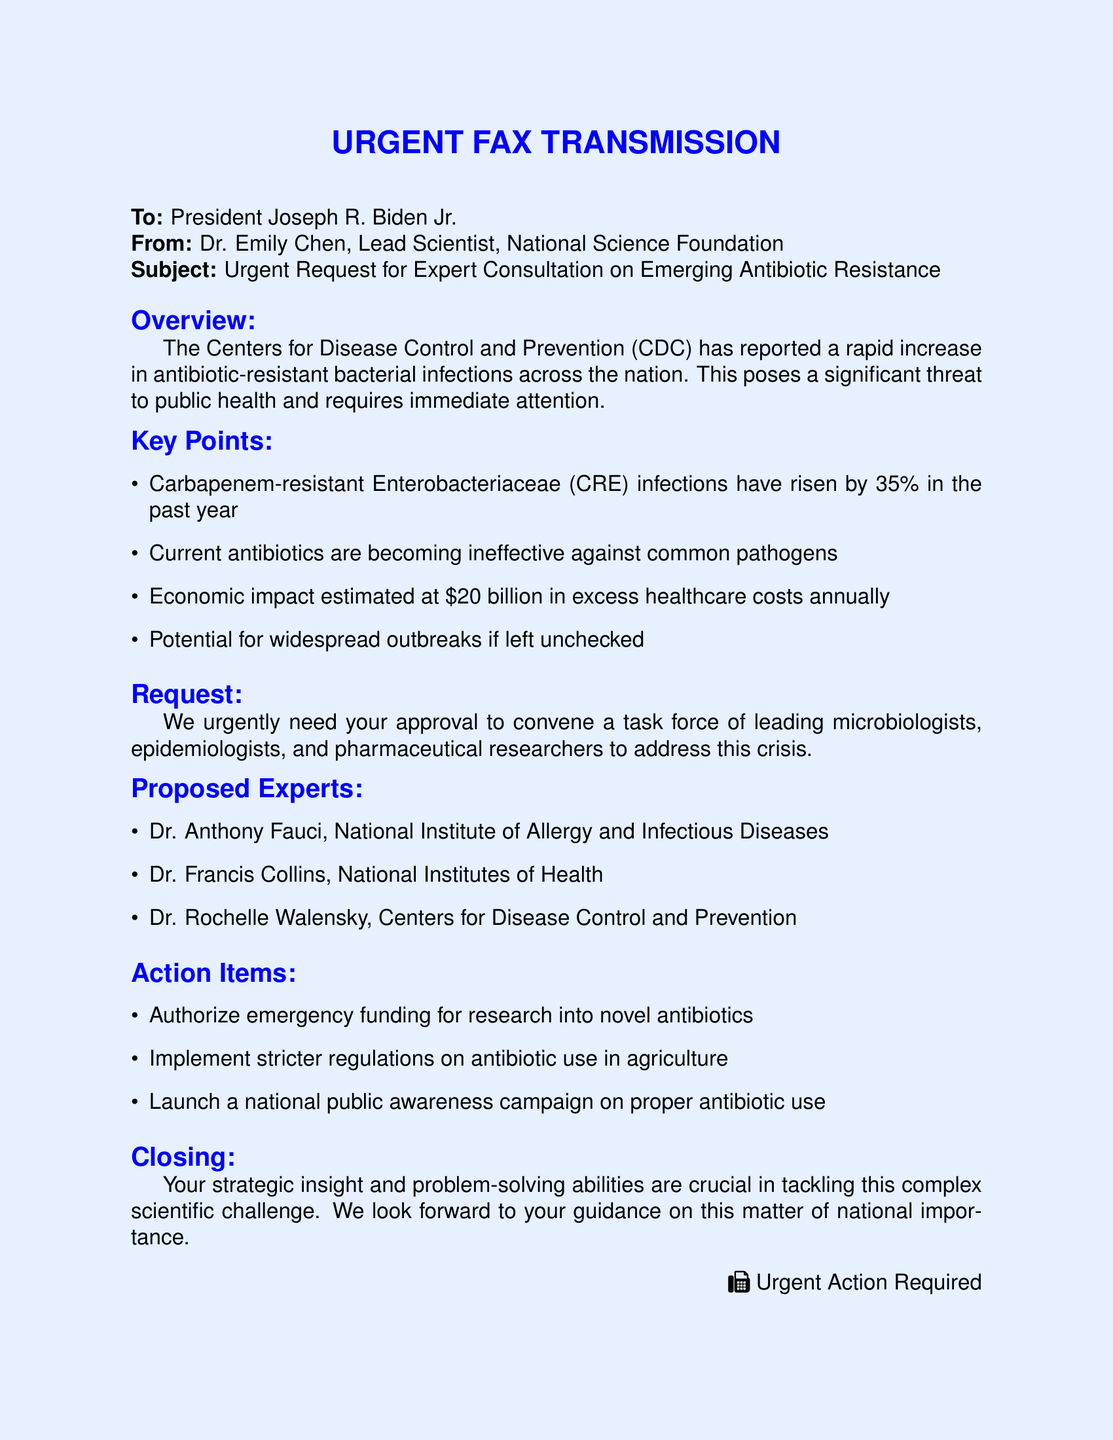What is the subject of this fax? The subject of the fax is about an urgent request for expert consultation on a scientific problem regarding antibiotic resistance.
Answer: Urgent Request for Expert Consultation on Emerging Antibiotic Resistance How much have Carbapenem-resistant Enterobacteriaceae infections risen by in the past year? The document states that Carbapenem-resistant Enterobacteriaceae infections have increased by a specific percentage in the past year.
Answer: 35% Who is the lead scientist at the National Science Foundation? The document identifies the person sending the fax and their title.
Answer: Dr. Emily Chen What is the estimated economic impact of antibiotic resistance mentioned? The economic impact in the document is quantified, representing annual excess healthcare costs.
Answer: $20 billion How many proposed experts are listed in the document? The document enumerates the individuals suggested to address the crisis and includes their titles.
Answer: 3 What does the document request from the President? The document specifies a need for approval related to forming a task force of experts.
Answer: Approval to convene a task force What is one of the action items proposed in the document? The document contains several listed actions regarding combating antibiotic resistance.
Answer: Authorize emergency funding for research into novel antibiotics What closing remarks are made in the fax? The closing section emphasizes the importance of the President's role in this national issue.
Answer: Your strategic insight and problem-solving abilities are crucial in tackling this complex scientific challenge 